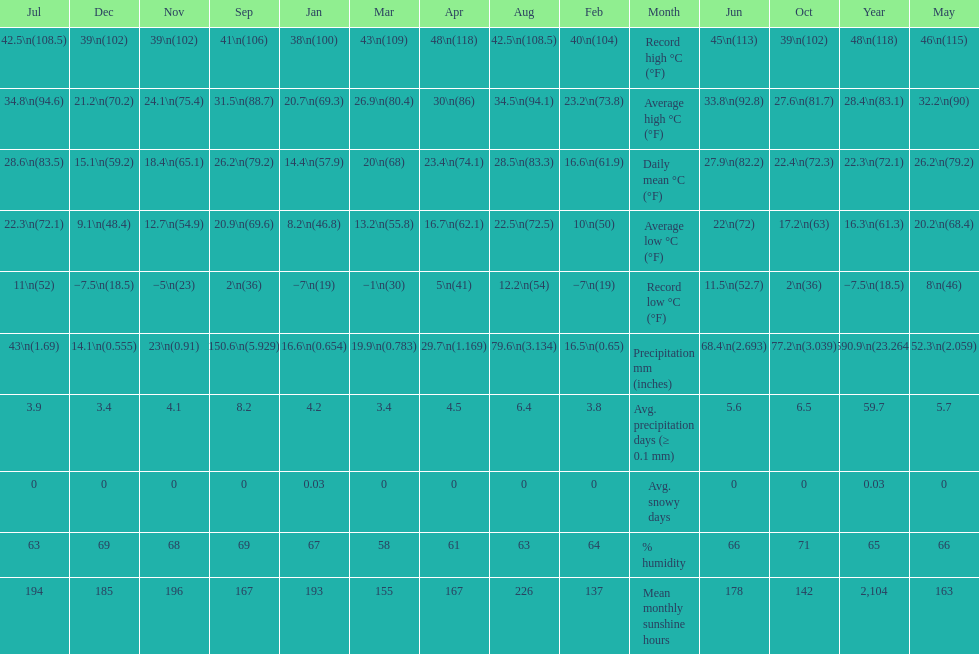Did march or april have more precipitation? April. 